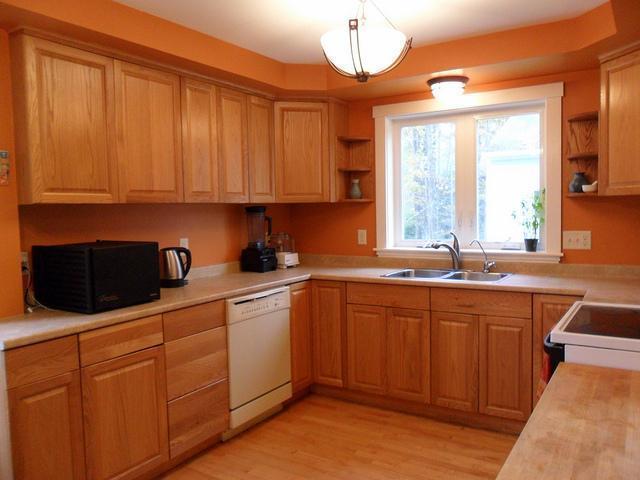What is the black appliance by the corner called?
Choose the correct response and explain in the format: 'Answer: answer
Rationale: rationale.'
Options: Food processor, can opener, blender, microwave. Answer: blender.
Rationale: The size, shape and location in the kitchen is consistent with answer a. What heats the stove for cooking?
Choose the correct response, then elucidate: 'Answer: answer
Rationale: rationale.'
Options: Wood, natural gas, coal, electricity. Answer: electricity.
Rationale: A kitchen has a range with a flat top rather than grates with pilot lights. 